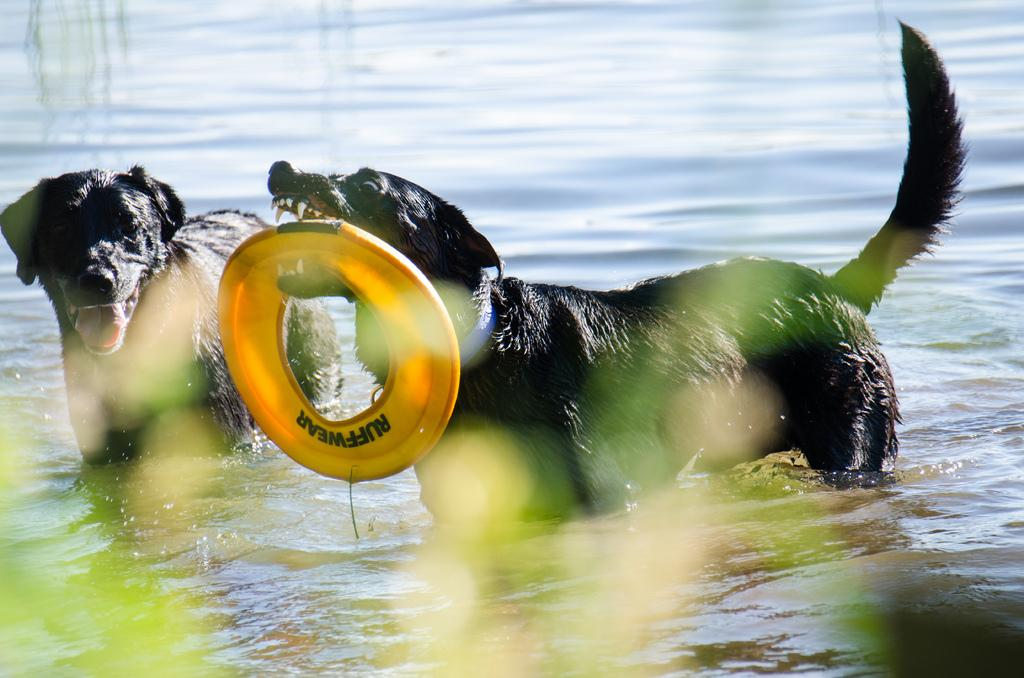How many dogs are in the image? There are two dogs in the image. What is one of the dogs doing in the image? One of the dogs is holding a disc. Which side of the image is the dog holding the disc on? The dog holding the disc is on the right side of the image. What can be seen at the bottom of the image? There is water visible at the bottom of the image. Where is the mother of the dogs in the image? There is no mother of the dogs present in the image. What type of flag is visible in the image? There is no flag present in the image. 